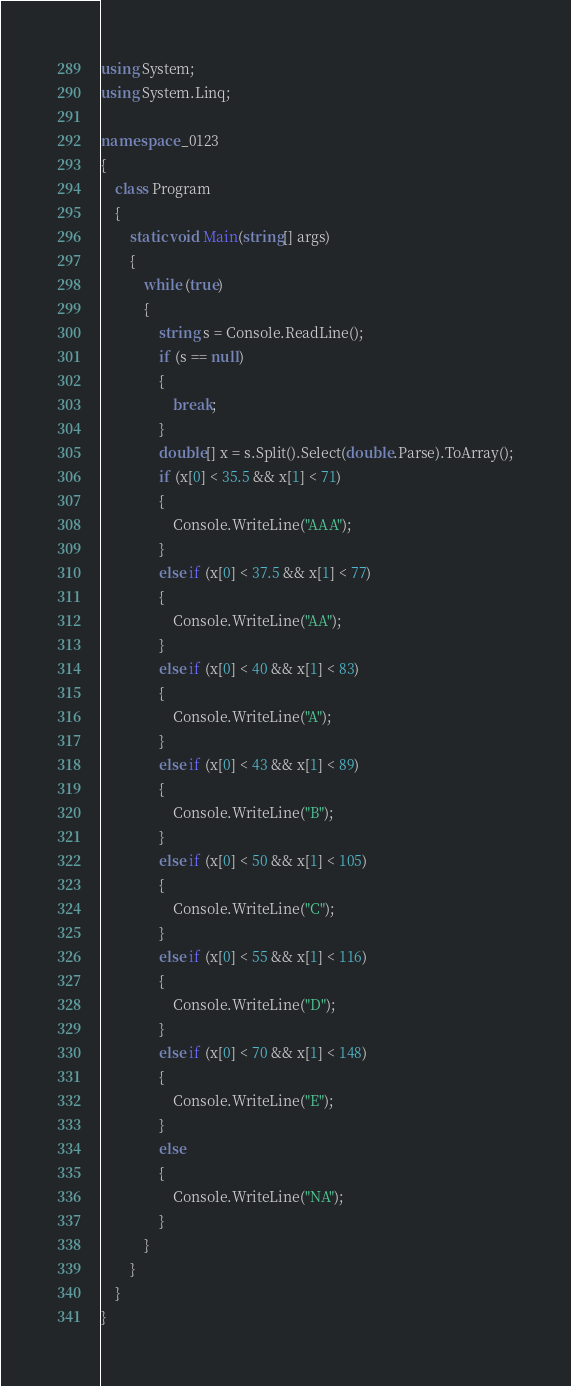Convert code to text. <code><loc_0><loc_0><loc_500><loc_500><_C#_>using System;
using System.Linq;

namespace _0123
{
    class Program
    {
        static void Main(string[] args)
        {
            while (true)
            {
                string s = Console.ReadLine();
                if (s == null)
                {
                    break;
                }
                double[] x = s.Split().Select(double.Parse).ToArray();
                if (x[0] < 35.5 && x[1] < 71)
                {
                    Console.WriteLine("AAA");
                }
                else if (x[0] < 37.5 && x[1] < 77)
                {
                    Console.WriteLine("AA");
                }
                else if (x[0] < 40 && x[1] < 83)
                {
                    Console.WriteLine("A");
                }
                else if (x[0] < 43 && x[1] < 89)
                {
                    Console.WriteLine("B");
                }
                else if (x[0] < 50 && x[1] < 105)
                {
                    Console.WriteLine("C");
                }
                else if (x[0] < 55 && x[1] < 116)
                {
                    Console.WriteLine("D");
                }
                else if (x[0] < 70 && x[1] < 148)
                {
                    Console.WriteLine("E");
                }
                else
                {
                    Console.WriteLine("NA");
                }
            }
        }
    }
}</code> 